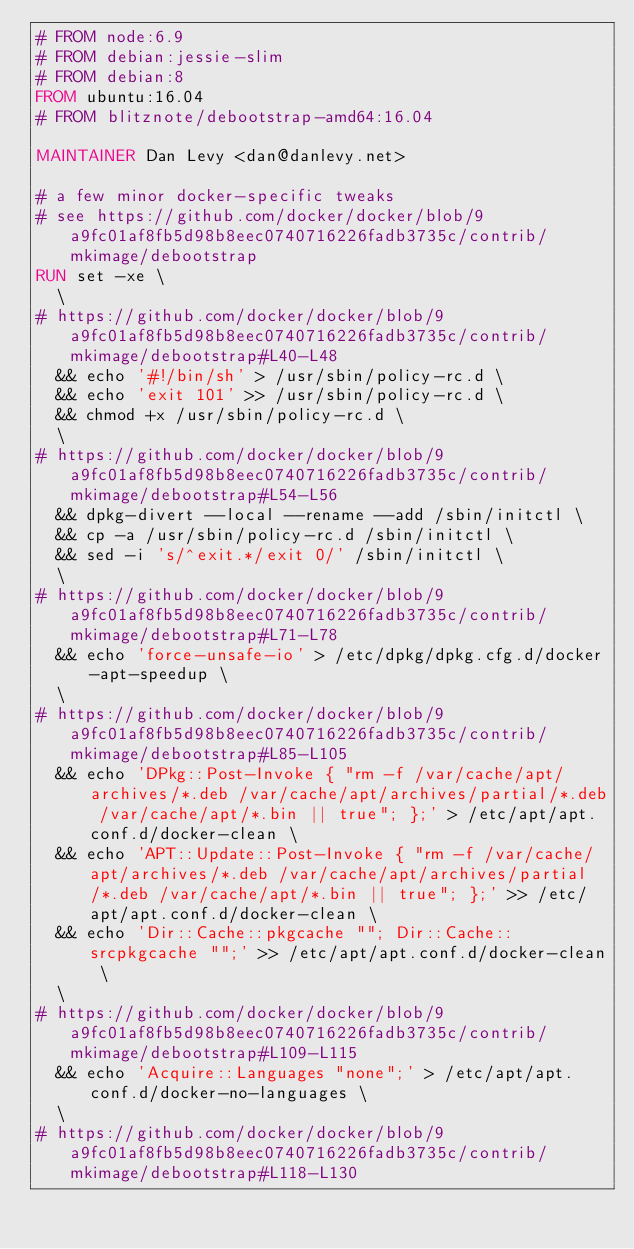Convert code to text. <code><loc_0><loc_0><loc_500><loc_500><_Dockerfile_># FROM node:6.9
# FROM debian:jessie-slim
# FROM debian:8
FROM ubuntu:16.04
# FROM blitznote/debootstrap-amd64:16.04

MAINTAINER Dan Levy <dan@danlevy.net>

# a few minor docker-specific tweaks
# see https://github.com/docker/docker/blob/9a9fc01af8fb5d98b8eec0740716226fadb3735c/contrib/mkimage/debootstrap
RUN set -xe \
  \
# https://github.com/docker/docker/blob/9a9fc01af8fb5d98b8eec0740716226fadb3735c/contrib/mkimage/debootstrap#L40-L48
  && echo '#!/bin/sh' > /usr/sbin/policy-rc.d \
  && echo 'exit 101' >> /usr/sbin/policy-rc.d \
  && chmod +x /usr/sbin/policy-rc.d \
  \
# https://github.com/docker/docker/blob/9a9fc01af8fb5d98b8eec0740716226fadb3735c/contrib/mkimage/debootstrap#L54-L56
  && dpkg-divert --local --rename --add /sbin/initctl \
  && cp -a /usr/sbin/policy-rc.d /sbin/initctl \
  && sed -i 's/^exit.*/exit 0/' /sbin/initctl \
  \
# https://github.com/docker/docker/blob/9a9fc01af8fb5d98b8eec0740716226fadb3735c/contrib/mkimage/debootstrap#L71-L78
  && echo 'force-unsafe-io' > /etc/dpkg/dpkg.cfg.d/docker-apt-speedup \
  \
# https://github.com/docker/docker/blob/9a9fc01af8fb5d98b8eec0740716226fadb3735c/contrib/mkimage/debootstrap#L85-L105
  && echo 'DPkg::Post-Invoke { "rm -f /var/cache/apt/archives/*.deb /var/cache/apt/archives/partial/*.deb /var/cache/apt/*.bin || true"; };' > /etc/apt/apt.conf.d/docker-clean \
  && echo 'APT::Update::Post-Invoke { "rm -f /var/cache/apt/archives/*.deb /var/cache/apt/archives/partial/*.deb /var/cache/apt/*.bin || true"; };' >> /etc/apt/apt.conf.d/docker-clean \
  && echo 'Dir::Cache::pkgcache ""; Dir::Cache::srcpkgcache "";' >> /etc/apt/apt.conf.d/docker-clean \
  \
# https://github.com/docker/docker/blob/9a9fc01af8fb5d98b8eec0740716226fadb3735c/contrib/mkimage/debootstrap#L109-L115
  && echo 'Acquire::Languages "none";' > /etc/apt/apt.conf.d/docker-no-languages \
  \
# https://github.com/docker/docker/blob/9a9fc01af8fb5d98b8eec0740716226fadb3735c/contrib/mkimage/debootstrap#L118-L130</code> 